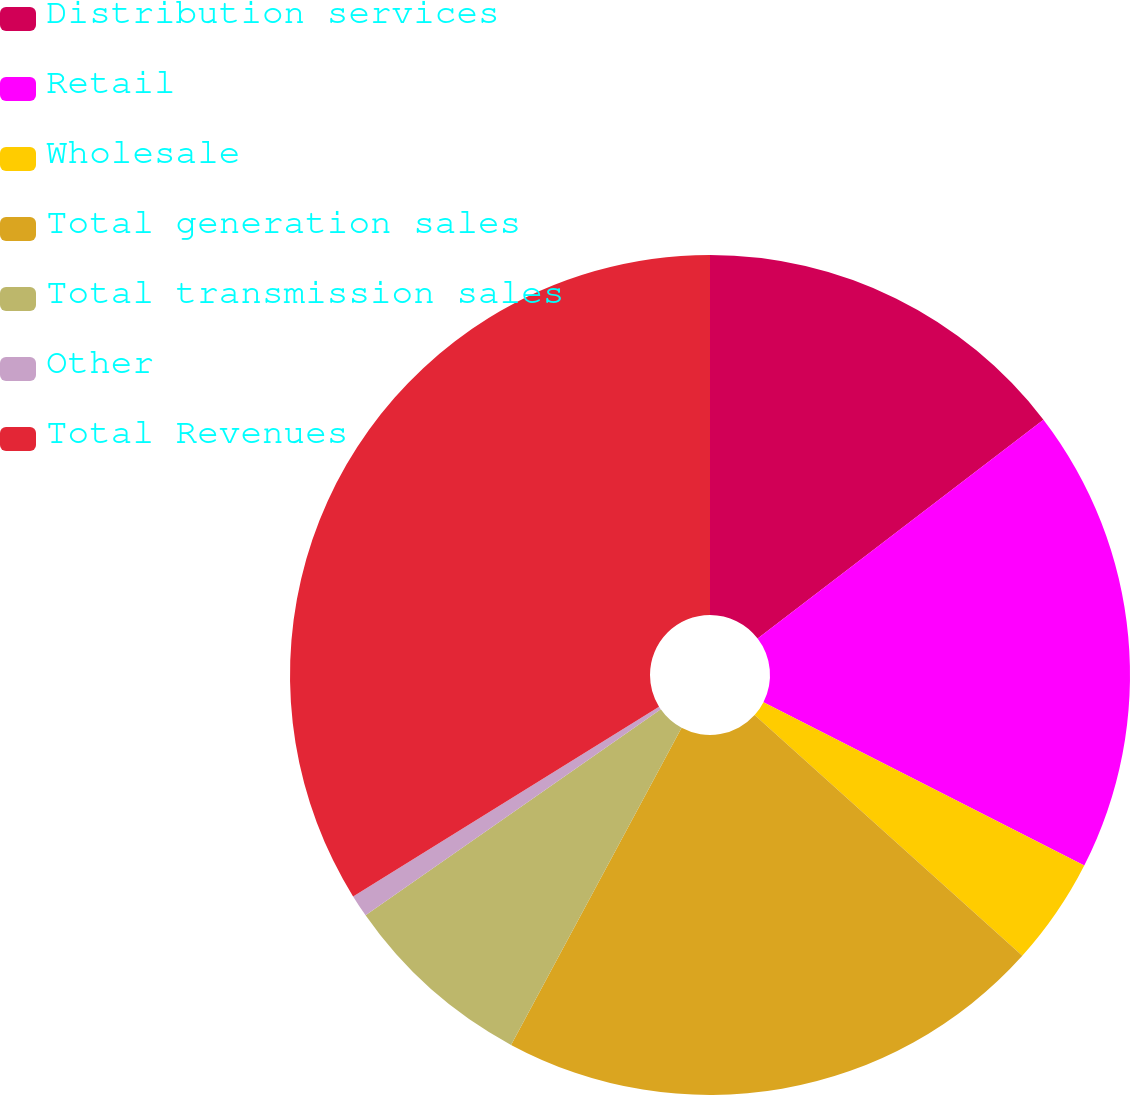Convert chart to OTSL. <chart><loc_0><loc_0><loc_500><loc_500><pie_chart><fcel>Distribution services<fcel>Retail<fcel>Wholesale<fcel>Total generation sales<fcel>Total transmission sales<fcel>Other<fcel>Total Revenues<nl><fcel>14.6%<fcel>17.9%<fcel>4.16%<fcel>21.2%<fcel>7.45%<fcel>0.86%<fcel>33.84%<nl></chart> 